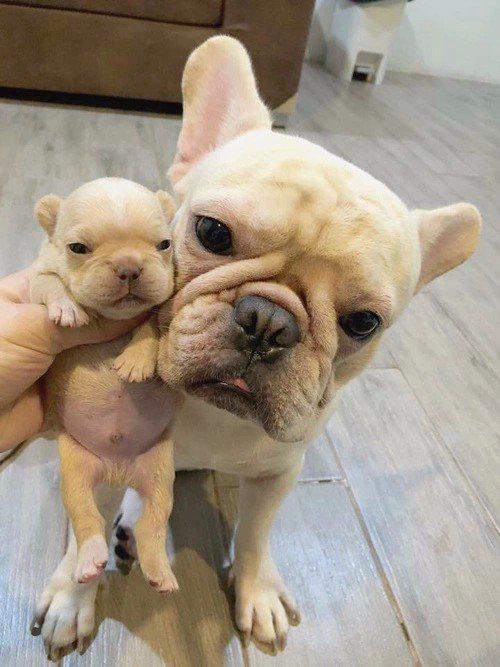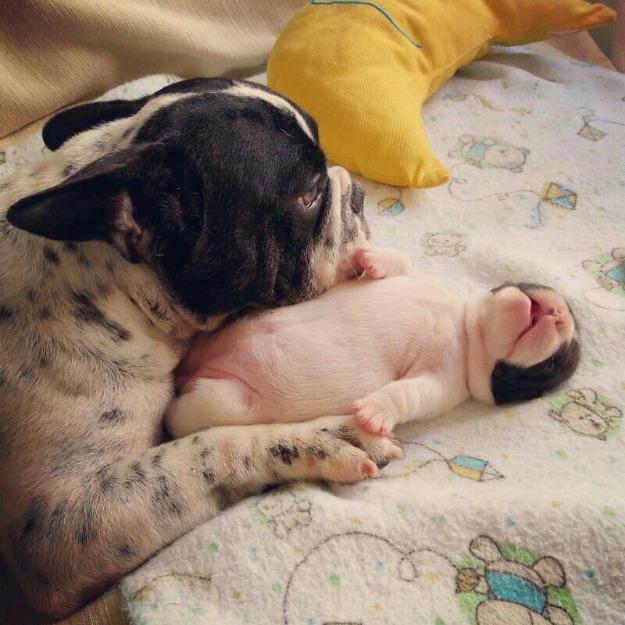The first image is the image on the left, the second image is the image on the right. Analyze the images presented: Is the assertion "An image shows a human child resting with at least one snoozing dog." valid? Answer yes or no. No. The first image is the image on the left, the second image is the image on the right. Analyze the images presented: Is the assertion "A young person is lying with at least one dog." valid? Answer yes or no. No. 